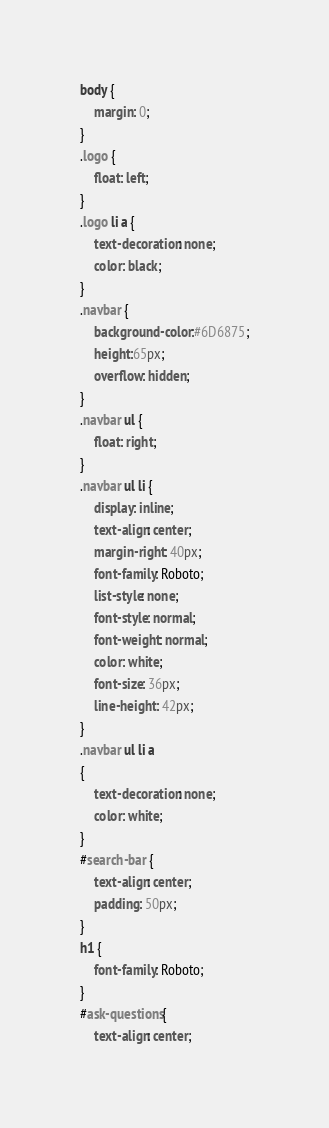Convert code to text. <code><loc_0><loc_0><loc_500><loc_500><_CSS_>body {
    margin: 0;
}
.logo {
    float: left;
}
.logo li a {
    text-decoration: none;
    color: black; 
}
.navbar {
    background-color:#6D6875;
    height:65px;
    overflow: hidden;
}
.navbar ul {
    float: right;
}
.navbar ul li {
    display: inline;
    text-align: center;
    margin-right: 40px;
    font-family: Roboto;
    list-style: none;
    font-style: normal;
    font-weight: normal;
    color: white;
    font-size: 36px;
    line-height: 42px;
}
.navbar ul li a 
{
    text-decoration: none;
    color: white;   
}
#search-bar {
    text-align: center;
    padding: 50px;
}
h1 {
    font-family: Roboto;
}
#ask-questions{
    text-align: center;</code> 